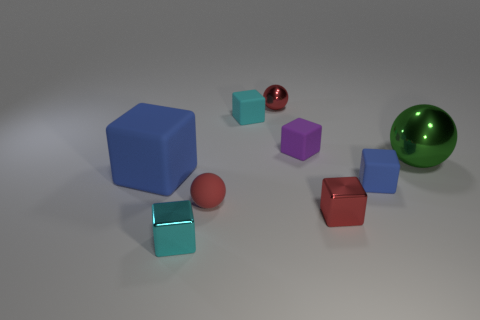How many other small red blocks have the same material as the red block?
Your answer should be very brief. 0. Do the metallic ball on the left side of the small purple rubber block and the cyan cube that is behind the large green metal sphere have the same size?
Your answer should be compact. Yes. The big thing right of the cyan rubber block is what color?
Offer a terse response. Green. What is the material of the other block that is the same color as the large block?
Provide a short and direct response. Rubber. What number of spheres are the same color as the big block?
Provide a short and direct response. 0. Is the size of the red block the same as the blue rubber thing that is left of the matte ball?
Your answer should be compact. No. What size is the metallic ball in front of the metallic ball behind the big object that is on the right side of the large rubber object?
Offer a very short reply. Large. There is a large blue matte block; how many tiny spheres are left of it?
Your response must be concise. 0. There is a cube right of the tiny red metallic object in front of the large cube; what is it made of?
Provide a succinct answer. Rubber. Are there any other things that have the same size as the cyan metallic object?
Keep it short and to the point. Yes. 